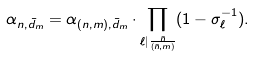Convert formula to latex. <formula><loc_0><loc_0><loc_500><loc_500>\alpha _ { n , \bar { d } _ { m } } = \alpha _ { ( n , m ) , \bar { d } _ { m } } \cdot \prod _ { \ell | \frac { \bar { n } } { ( \bar { n } , m ) } } ( 1 - \sigma _ { \ell } ^ { - 1 } ) .</formula> 